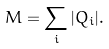Convert formula to latex. <formula><loc_0><loc_0><loc_500><loc_500>M = \sum _ { i } | Q _ { i } | .</formula> 